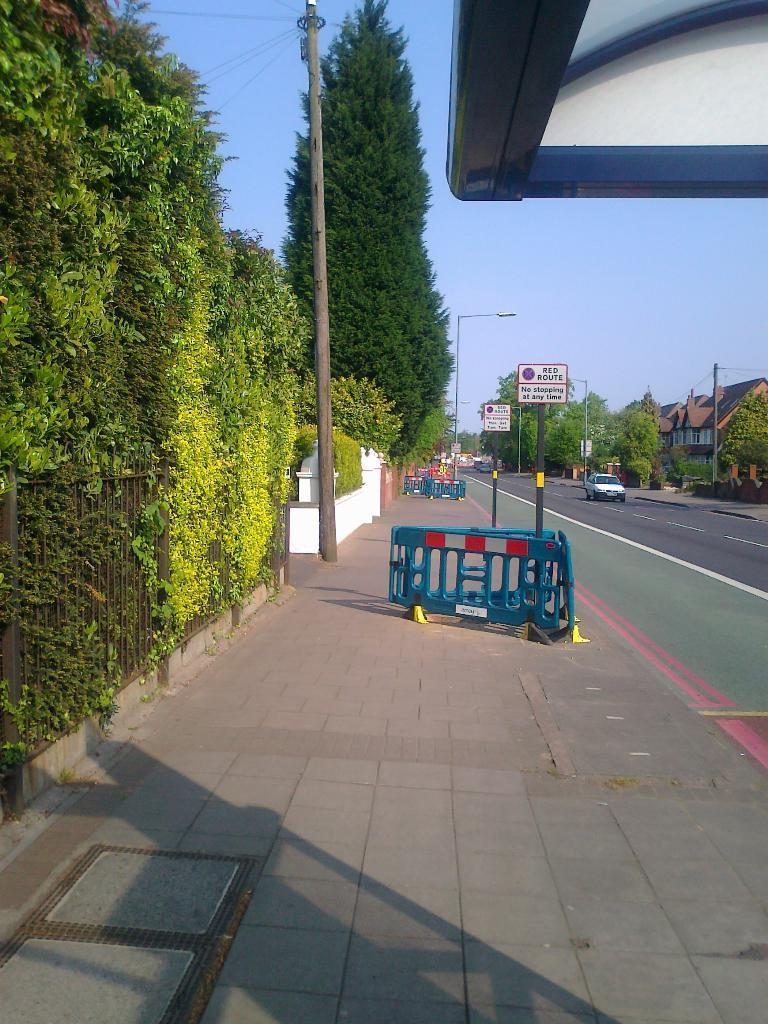Please provide a concise description of this image. In the image,there is a road and there is a vehicle moving on the road,beside the road on a footpath there are two caution boards,a street light and beside the street light there are plenty of trees and on the other side of the road there is a big house and few trees around the house. 